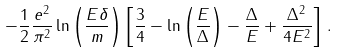<formula> <loc_0><loc_0><loc_500><loc_500>- \frac { 1 } { 2 } \frac { e ^ { 2 } } { \pi ^ { 2 } } \ln \left ( \frac { E \delta } m \right ) \left [ \frac { 3 } { 4 } - \ln \left ( \frac { E } { \Delta } \right ) - \frac { \Delta } { E } + \frac { \Delta ^ { 2 } } { 4 E ^ { 2 } } \right ] \, .</formula> 